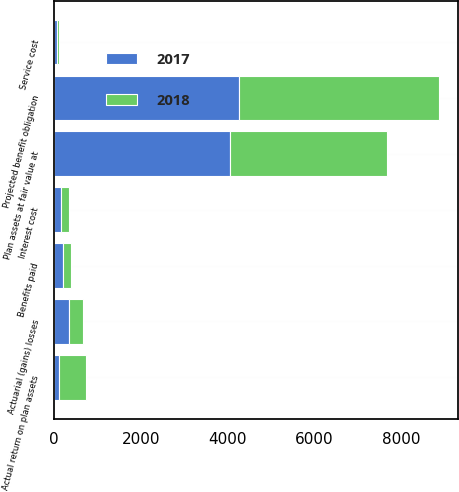Convert chart. <chart><loc_0><loc_0><loc_500><loc_500><stacked_bar_chart><ecel><fcel>Projected benefit obligation<fcel>Service cost<fcel>Interest cost<fcel>Actuarial (gains) losses<fcel>Benefits paid<fcel>Plan assets at fair value at<fcel>Actual return on plan assets<nl><fcel>2017<fcel>4278<fcel>59<fcel>167<fcel>349<fcel>202<fcel>4058<fcel>112<nl><fcel>2018<fcel>4603<fcel>57<fcel>175<fcel>325<fcel>194<fcel>3625<fcel>622<nl></chart> 